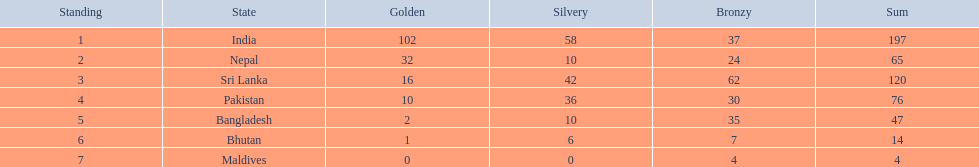What country has won no silver medals? Maldives. 